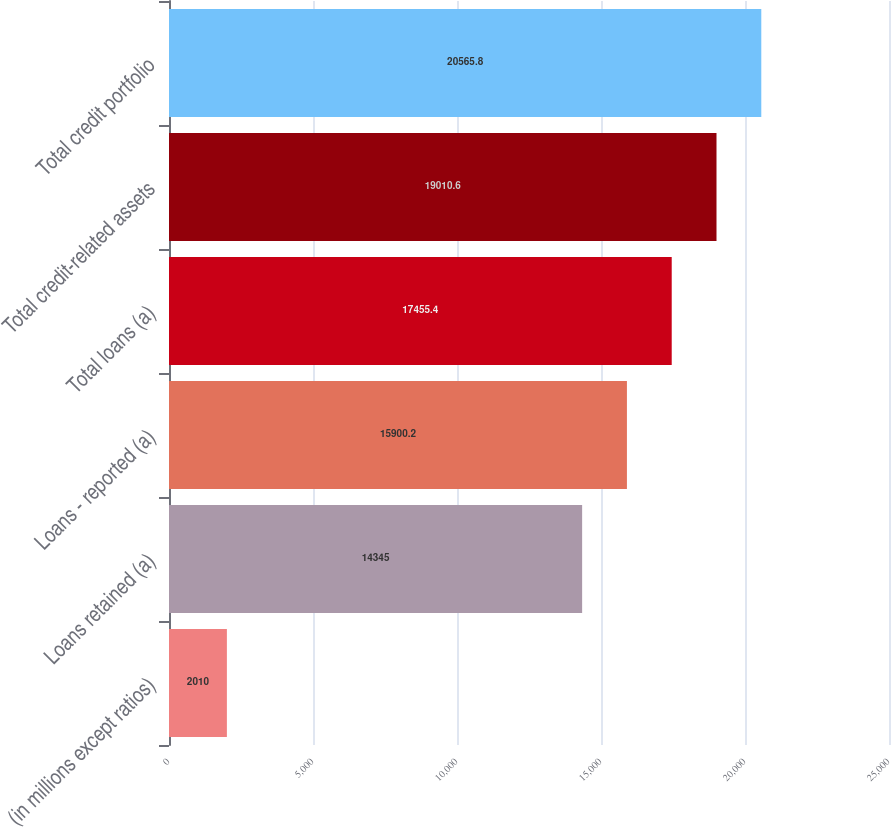Convert chart. <chart><loc_0><loc_0><loc_500><loc_500><bar_chart><fcel>(in millions except ratios)<fcel>Loans retained (a)<fcel>Loans - reported (a)<fcel>Total loans (a)<fcel>Total credit-related assets<fcel>Total credit portfolio<nl><fcel>2010<fcel>14345<fcel>15900.2<fcel>17455.4<fcel>19010.6<fcel>20565.8<nl></chart> 